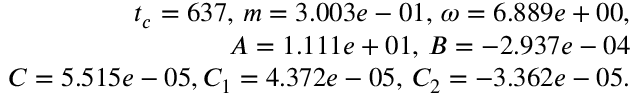<formula> <loc_0><loc_0><loc_500><loc_500>\begin{array} { r } { t _ { c } = 6 3 7 , \, m = 3 . 0 0 3 e - 0 1 , \, \omega = 6 . 8 8 9 e + 0 0 , } \\ { A = 1 . 1 1 1 e + 0 1 , \, B = - 2 . 9 3 7 e - 0 4 } \\ { C = 5 . 5 1 5 e - 0 5 , C _ { 1 } = 4 . 3 7 2 e - 0 5 , \, C _ { 2 } = - 3 . 3 6 2 e - 0 5 . } \end{array}</formula> 